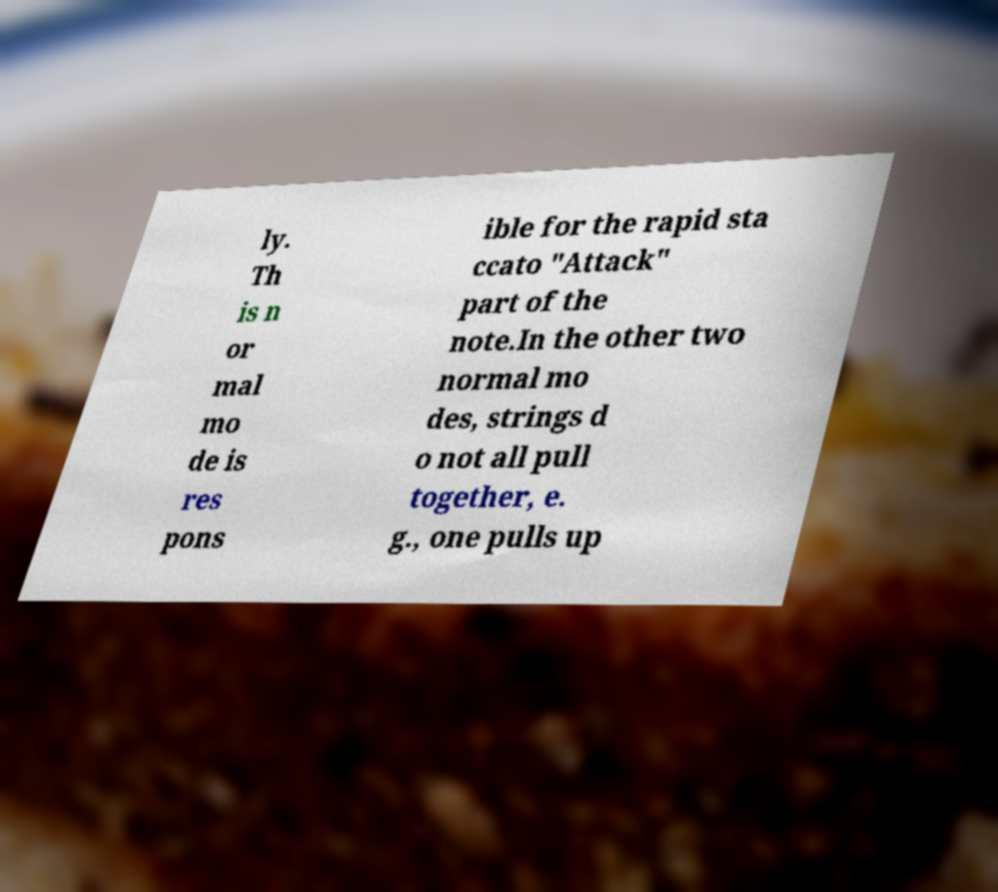Could you extract and type out the text from this image? ly. Th is n or mal mo de is res pons ible for the rapid sta ccato "Attack" part of the note.In the other two normal mo des, strings d o not all pull together, e. g., one pulls up 